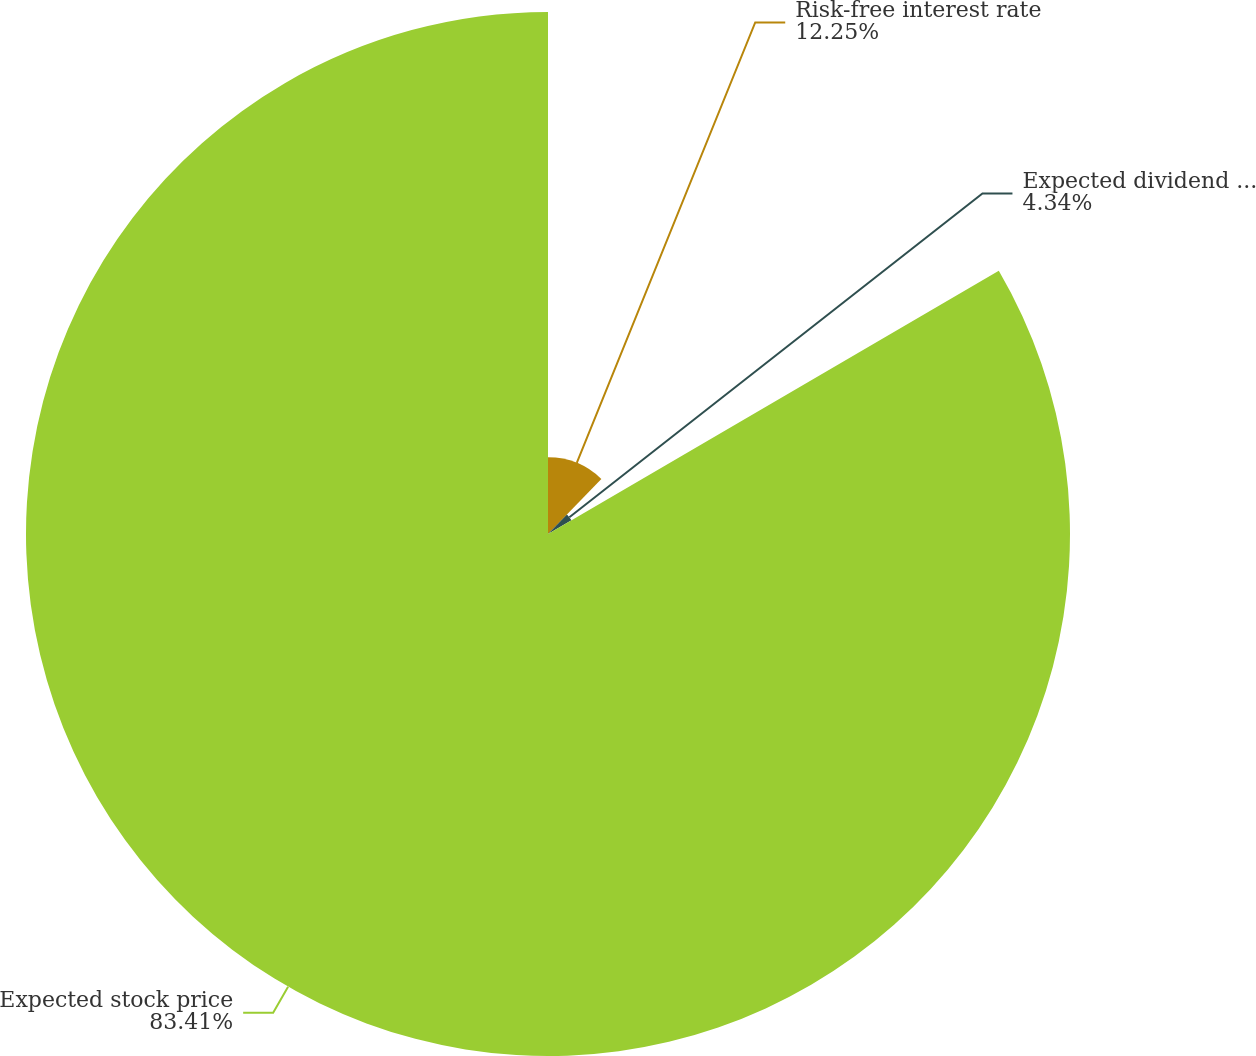Convert chart. <chart><loc_0><loc_0><loc_500><loc_500><pie_chart><fcel>Risk-free interest rate<fcel>Expected dividend yield<fcel>Expected stock price<nl><fcel>12.25%<fcel>4.34%<fcel>83.41%<nl></chart> 